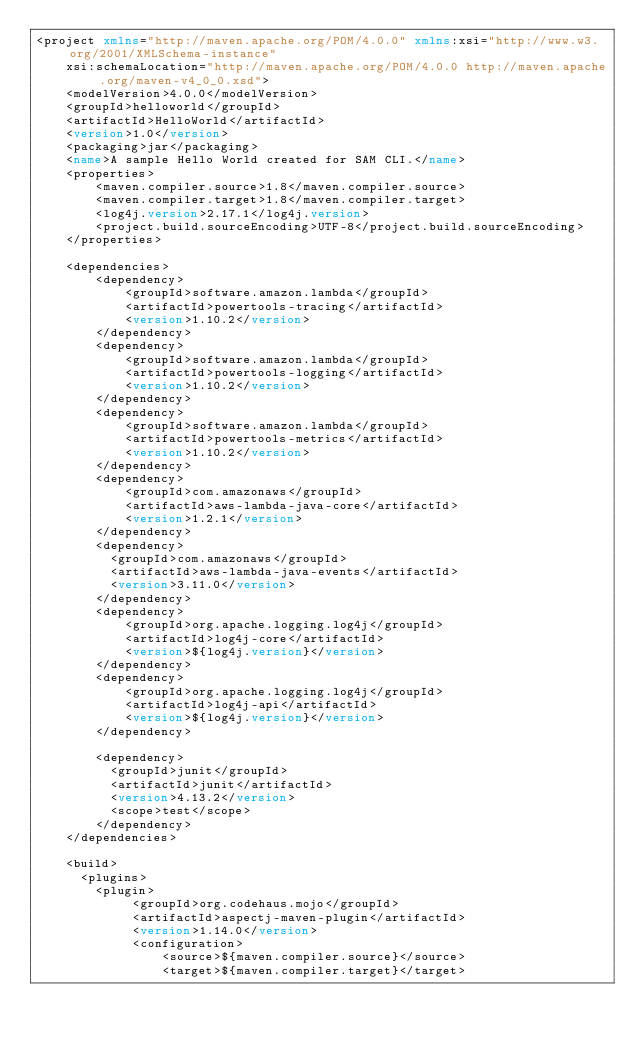Convert code to text. <code><loc_0><loc_0><loc_500><loc_500><_XML_><project xmlns="http://maven.apache.org/POM/4.0.0" xmlns:xsi="http://www.w3.org/2001/XMLSchema-instance"
    xsi:schemaLocation="http://maven.apache.org/POM/4.0.0 http://maven.apache.org/maven-v4_0_0.xsd">
    <modelVersion>4.0.0</modelVersion>
    <groupId>helloworld</groupId>
    <artifactId>HelloWorld</artifactId>
    <version>1.0</version>
    <packaging>jar</packaging>
    <name>A sample Hello World created for SAM CLI.</name>
    <properties>
        <maven.compiler.source>1.8</maven.compiler.source>
        <maven.compiler.target>1.8</maven.compiler.target>
        <log4j.version>2.17.1</log4j.version>
        <project.build.sourceEncoding>UTF-8</project.build.sourceEncoding>
    </properties>

    <dependencies>
        <dependency>
            <groupId>software.amazon.lambda</groupId>
            <artifactId>powertools-tracing</artifactId>
            <version>1.10.2</version>
        </dependency>
        <dependency>
            <groupId>software.amazon.lambda</groupId>
            <artifactId>powertools-logging</artifactId>
            <version>1.10.2</version>
        </dependency>
        <dependency>
            <groupId>software.amazon.lambda</groupId>
            <artifactId>powertools-metrics</artifactId>
            <version>1.10.2</version>
        </dependency>
        <dependency>
            <groupId>com.amazonaws</groupId>
            <artifactId>aws-lambda-java-core</artifactId>
            <version>1.2.1</version>
        </dependency>
        <dependency>
          <groupId>com.amazonaws</groupId>
          <artifactId>aws-lambda-java-events</artifactId>
          <version>3.11.0</version>
        </dependency>
        <dependency>
            <groupId>org.apache.logging.log4j</groupId>
            <artifactId>log4j-core</artifactId>
            <version>${log4j.version}</version>
        </dependency>
        <dependency>
            <groupId>org.apache.logging.log4j</groupId>
            <artifactId>log4j-api</artifactId>
            <version>${log4j.version}</version>
        </dependency>

        <dependency>
          <groupId>junit</groupId>
          <artifactId>junit</artifactId>
          <version>4.13.2</version>
          <scope>test</scope>
        </dependency>
    </dependencies>

    <build>
      <plugins>
        <plugin>
             <groupId>org.codehaus.mojo</groupId>
             <artifactId>aspectj-maven-plugin</artifactId>
             <version>1.14.0</version>
             <configuration>
                 <source>${maven.compiler.source}</source>
                 <target>${maven.compiler.target}</target></code> 